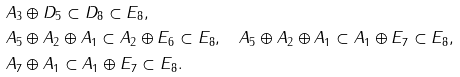Convert formula to latex. <formula><loc_0><loc_0><loc_500><loc_500>& A _ { 3 } \oplus D _ { 5 } \subset D _ { 8 } \subset E _ { 8 } , \\ & A _ { 5 } \oplus A _ { 2 } \oplus A _ { 1 } \subset A _ { 2 } \oplus E _ { 6 } \subset E _ { 8 } , \quad A _ { 5 } \oplus A _ { 2 } \oplus A _ { 1 } \subset A _ { 1 } \oplus E _ { 7 } \subset E _ { 8 } , \\ & A _ { 7 } \oplus A _ { 1 } \subset A _ { 1 } \oplus E _ { 7 } \subset E _ { 8 } .</formula> 